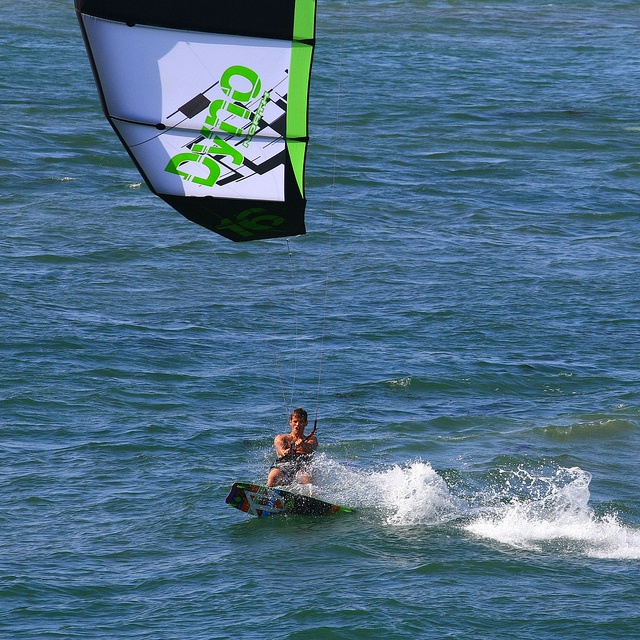Describe the objects in this image and their specific colors. I can see kite in gray, black, and lavender tones, people in gray, black, maroon, and darkgray tones, and surfboard in gray, black, blue, and darkgreen tones in this image. 